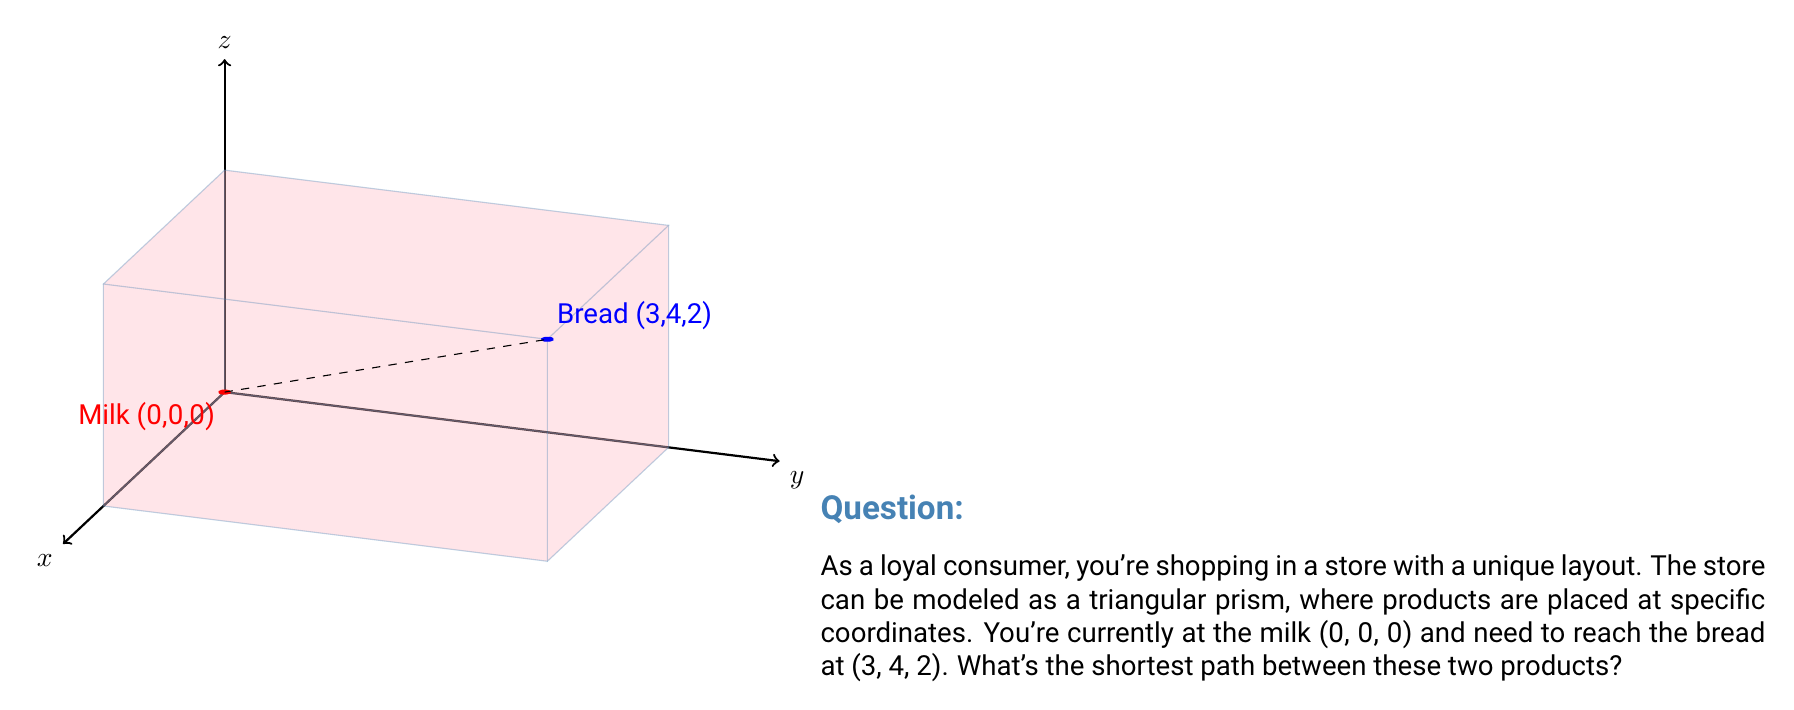What is the answer to this math problem? To find the shortest path between two points in a 3D space, we can use the distance formula in three dimensions:

$$d = \sqrt{(x_2-x_1)^2 + (y_2-y_1)^2 + (z_2-z_1)^2}$$

Where $(x_1,y_1,z_1)$ is the starting point (milk) and $(x_2,y_2,z_2)$ is the ending point (bread).

Let's substitute the values:

$(x_1,y_1,z_1) = (0,0,0)$
$(x_2,y_2,z_2) = (3,4,2)$

Now, let's calculate:

$$\begin{align}
d &= \sqrt{(3-0)^2 + (4-0)^2 + (2-0)^2} \\
&= \sqrt{3^2 + 4^2 + 2^2} \\
&= \sqrt{9 + 16 + 4} \\
&= \sqrt{29} \\
&\approx 5.385
\end{align}$$

The shortest path is a straight line between the two points, which is represented by the dashed line in the diagram. This path has a length of $\sqrt{29}$ units.
Answer: $\sqrt{29}$ units 